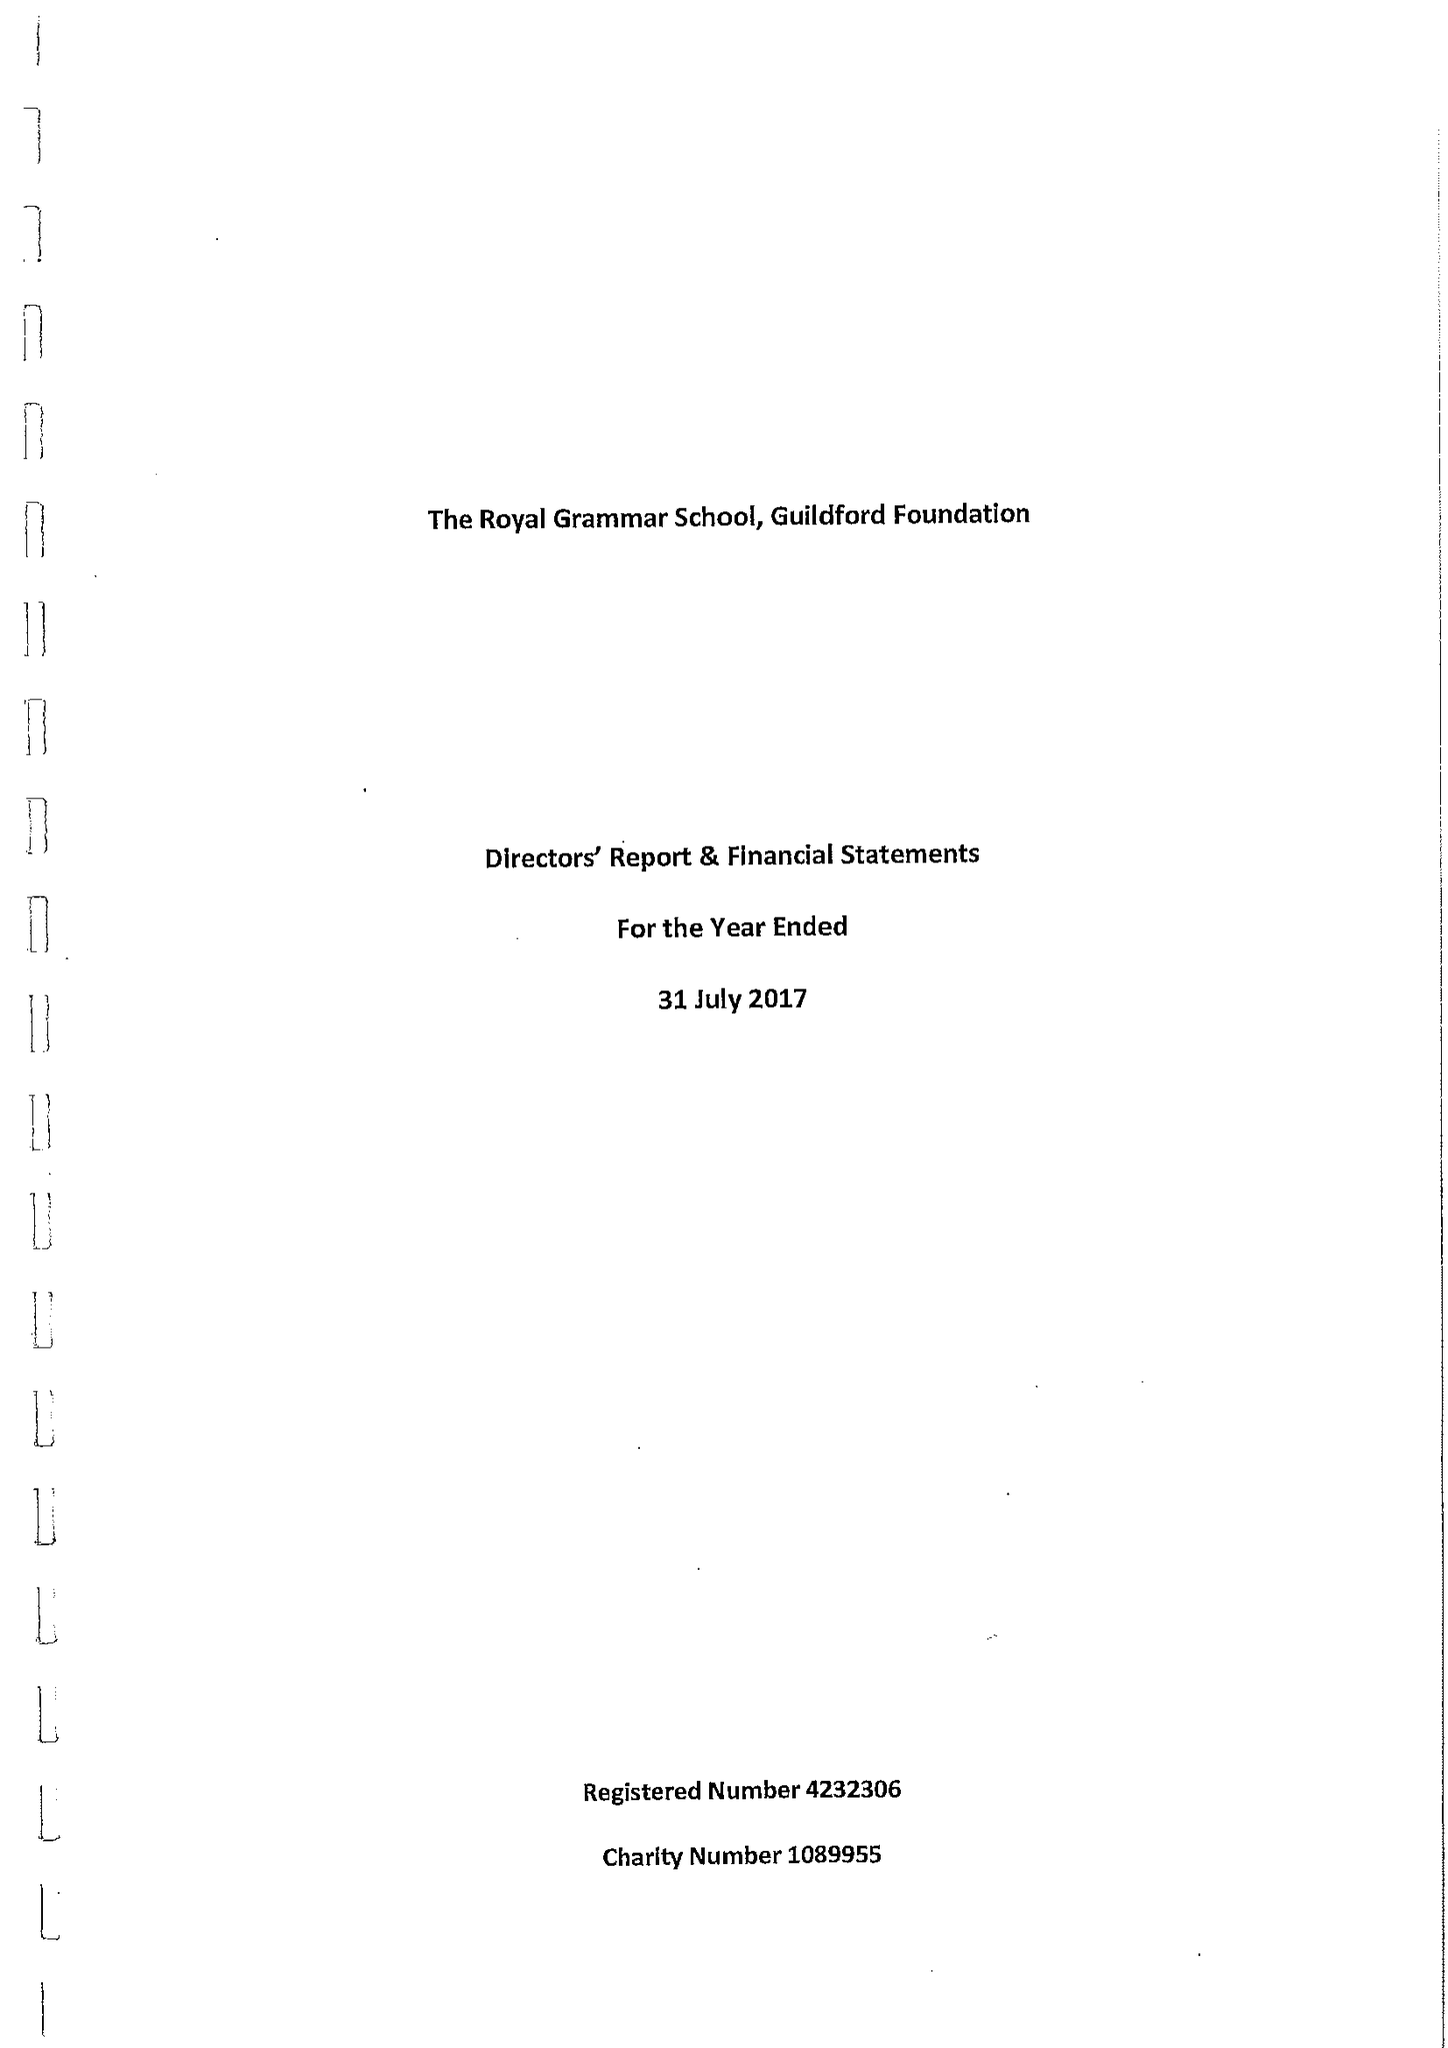What is the value for the income_annually_in_british_pounds?
Answer the question using a single word or phrase. 282150.00 